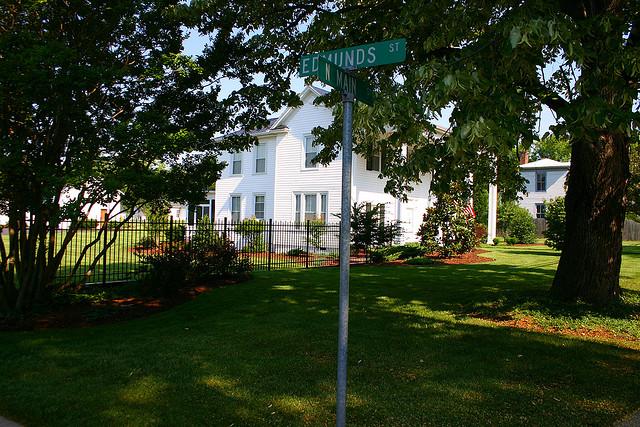What language are the signs written in?
Short answer required. English. What is the name of this street?
Answer briefly. Edmunds. Do you see a shadow of a person?
Keep it brief. No. What kind of trees are in the park?
Answer briefly. Oak. Is this a park?
Answer briefly. No. Is this a forest?
Concise answer only. No. How many vases are in the photo?
Keep it brief. 0. Is it a sunny day?
Write a very short answer. Yes. Is there any writing on these windows?
Be succinct. No. Is it dreary weather?
Be succinct. No. Are there leaves on all of the trees?
Be succinct. Yes. What do the signs say in this picture?
Quick response, please. Edmunds. Are those trees young?
Short answer required. No. What is the name of the road?
Be succinct. Edmunds. Is there a garden tool against the tree?
Give a very brief answer. No. Are the tree tall?
Keep it brief. Yes. Are there any buildings?
Concise answer only. Yes. Is there a glare in the photo?
Write a very short answer. No. What color is the house?
Give a very brief answer. White. Does that look like an effective fence?
Be succinct. Yes. What does the sign say?
Write a very short answer. Edmunds st. Are there leaves on the tree?
Write a very short answer. Yes. 